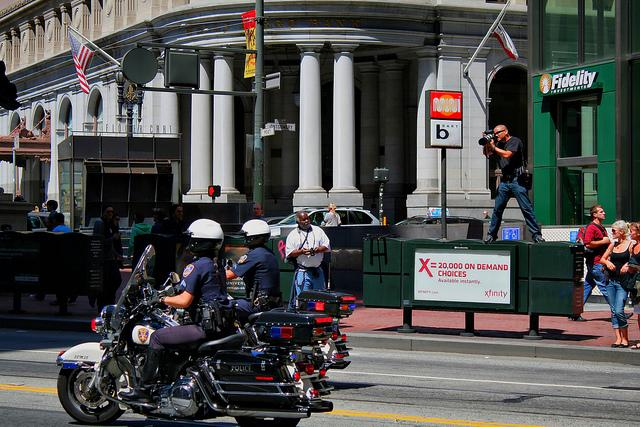What is the man standing on the green sign doing? Please explain your reasoning. photographing. The man has a camera in his hand. cameras take pictures and record videos. 